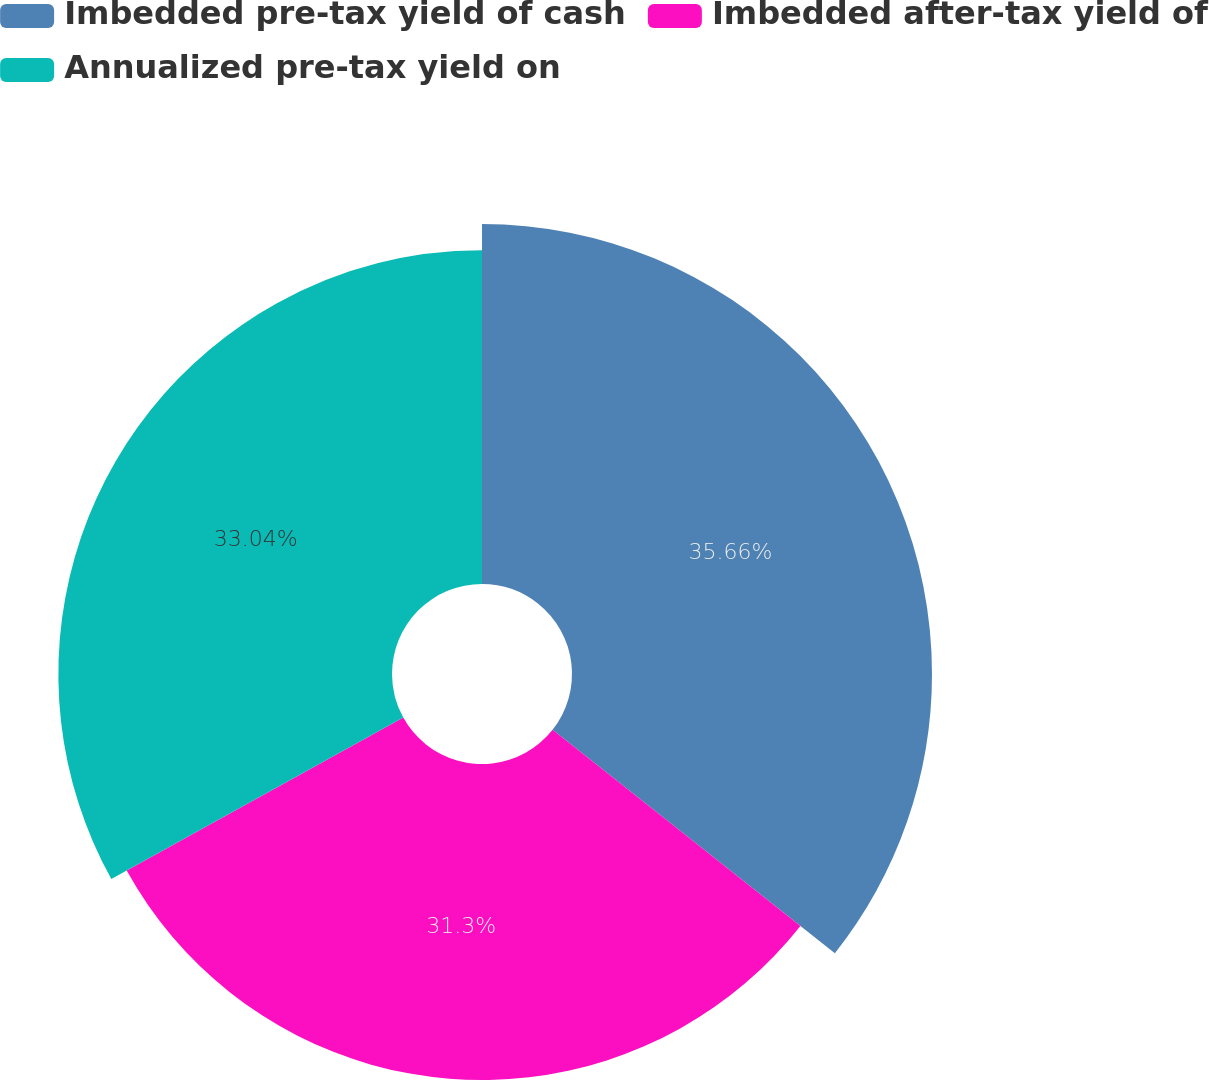<chart> <loc_0><loc_0><loc_500><loc_500><pie_chart><fcel>Imbedded pre-tax yield of cash<fcel>Imbedded after-tax yield of<fcel>Annualized pre-tax yield on<nl><fcel>35.65%<fcel>31.3%<fcel>33.04%<nl></chart> 